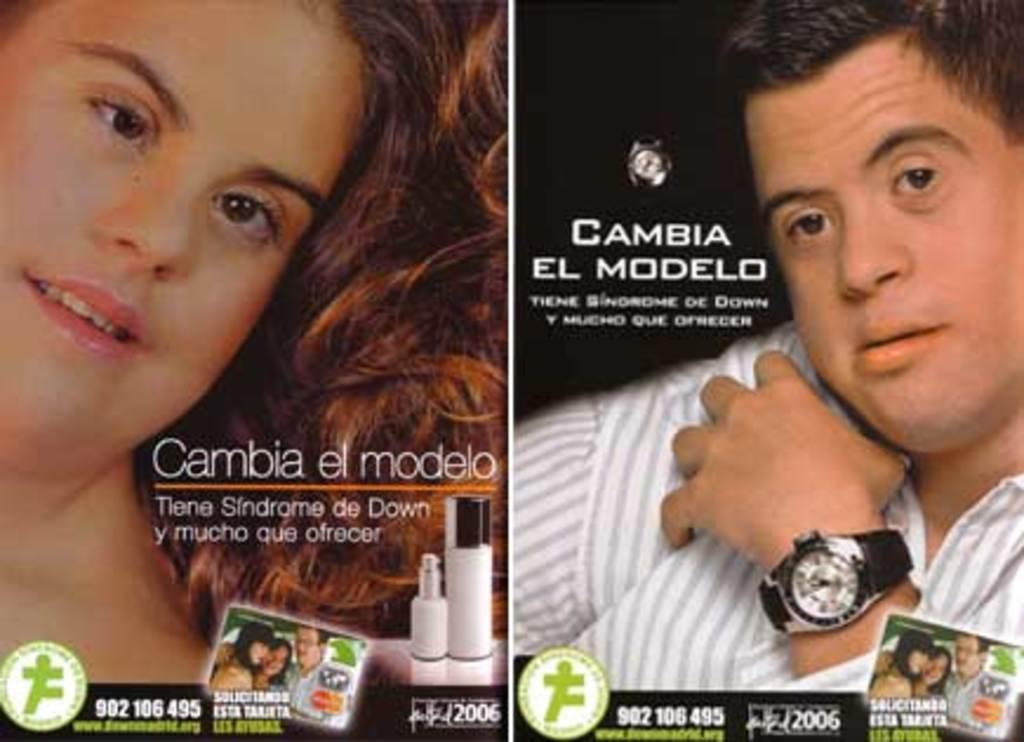<image>
Present a compact description of the photo's key features. Cambia El Modelo advertisement poster shows two people and writing in a foreign language. 